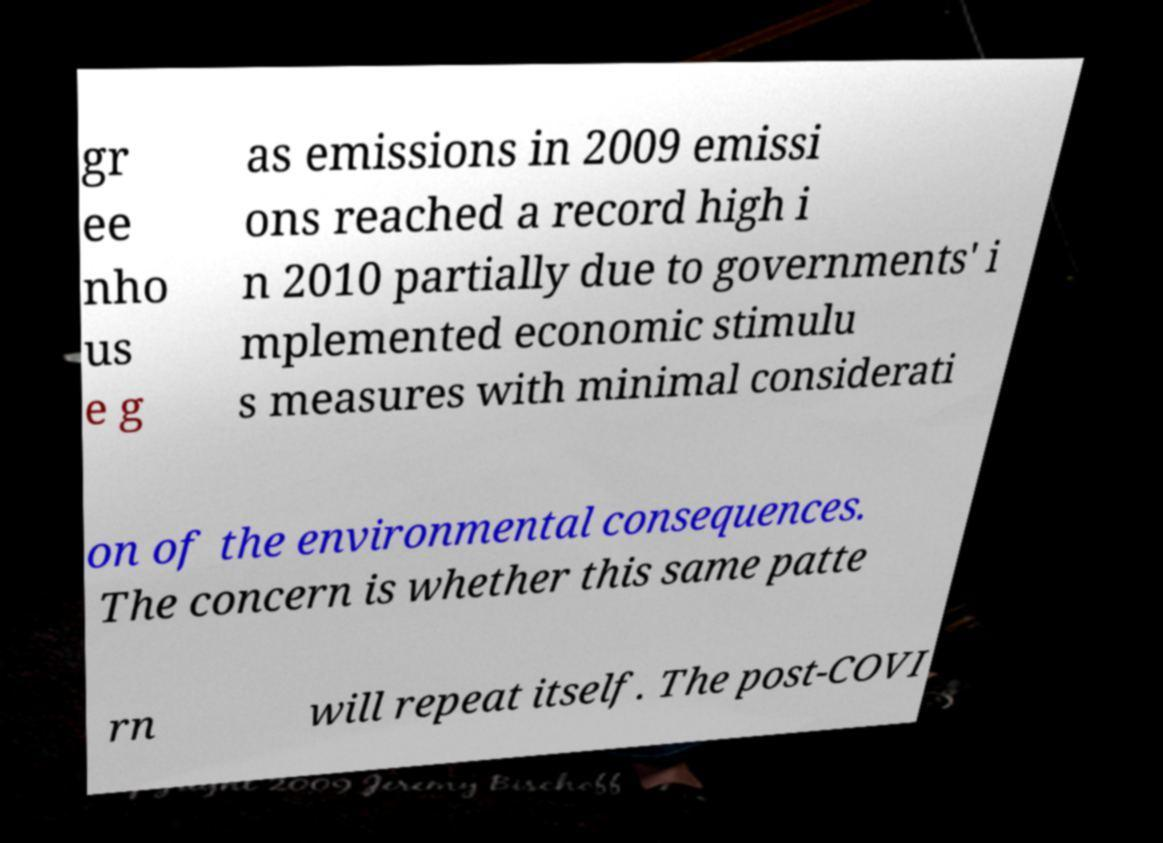I need the written content from this picture converted into text. Can you do that? gr ee nho us e g as emissions in 2009 emissi ons reached a record high i n 2010 partially due to governments' i mplemented economic stimulu s measures with minimal considerati on of the environmental consequences. The concern is whether this same patte rn will repeat itself. The post-COVI 